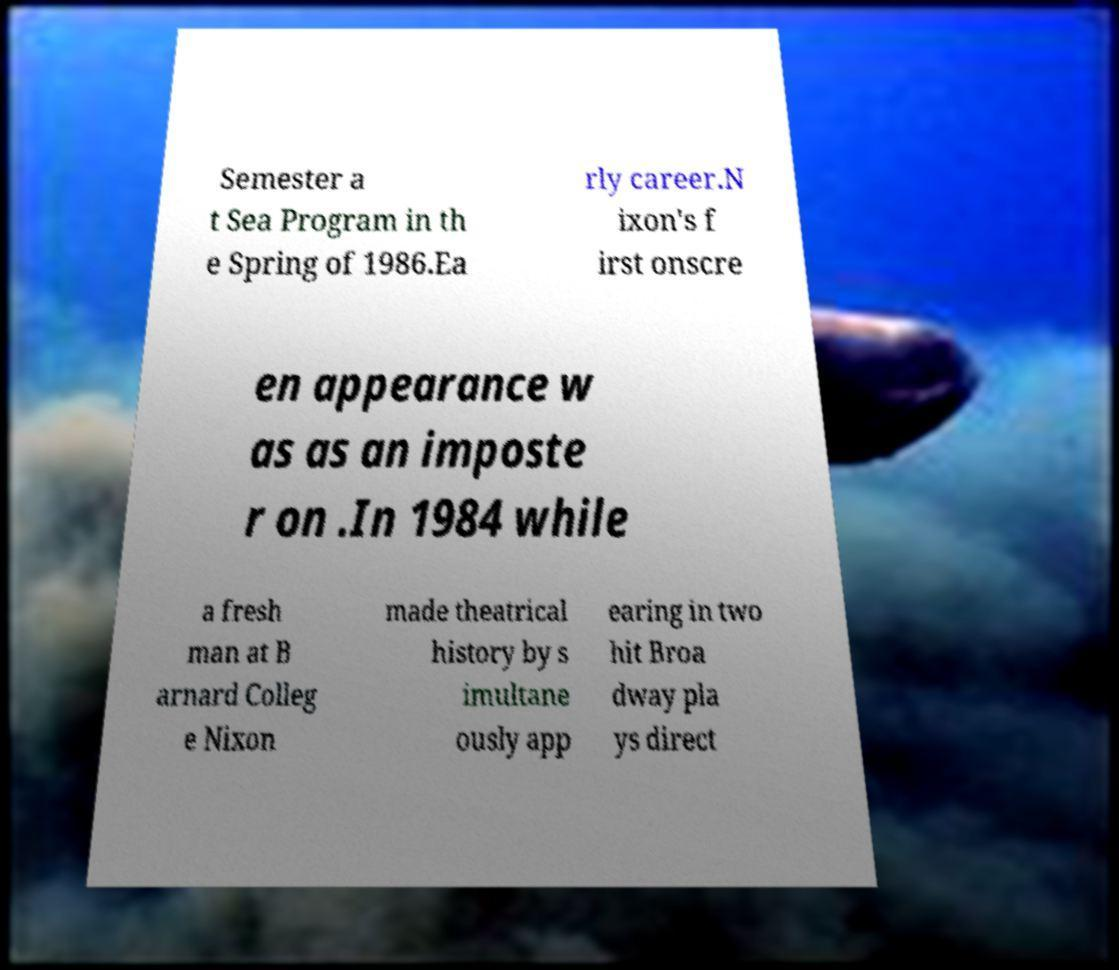I need the written content from this picture converted into text. Can you do that? Semester a t Sea Program in th e Spring of 1986.Ea rly career.N ixon's f irst onscre en appearance w as as an imposte r on .In 1984 while a fresh man at B arnard Colleg e Nixon made theatrical history by s imultane ously app earing in two hit Broa dway pla ys direct 